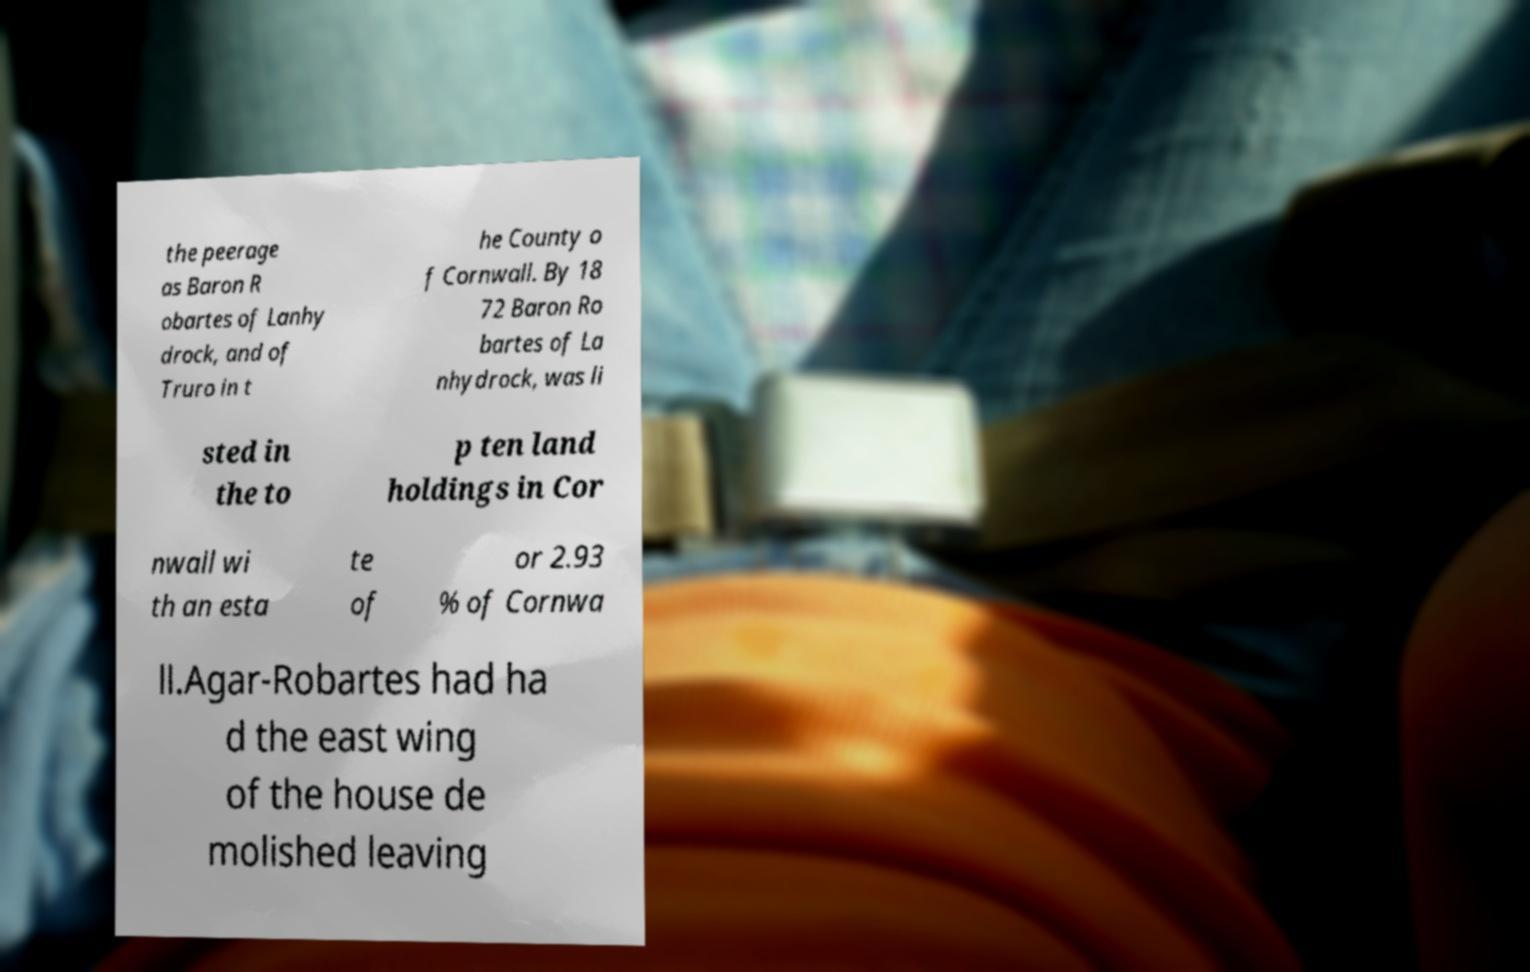For documentation purposes, I need the text within this image transcribed. Could you provide that? the peerage as Baron R obartes of Lanhy drock, and of Truro in t he County o f Cornwall. By 18 72 Baron Ro bartes of La nhydrock, was li sted in the to p ten land holdings in Cor nwall wi th an esta te of or 2.93 % of Cornwa ll.Agar-Robartes had ha d the east wing of the house de molished leaving 